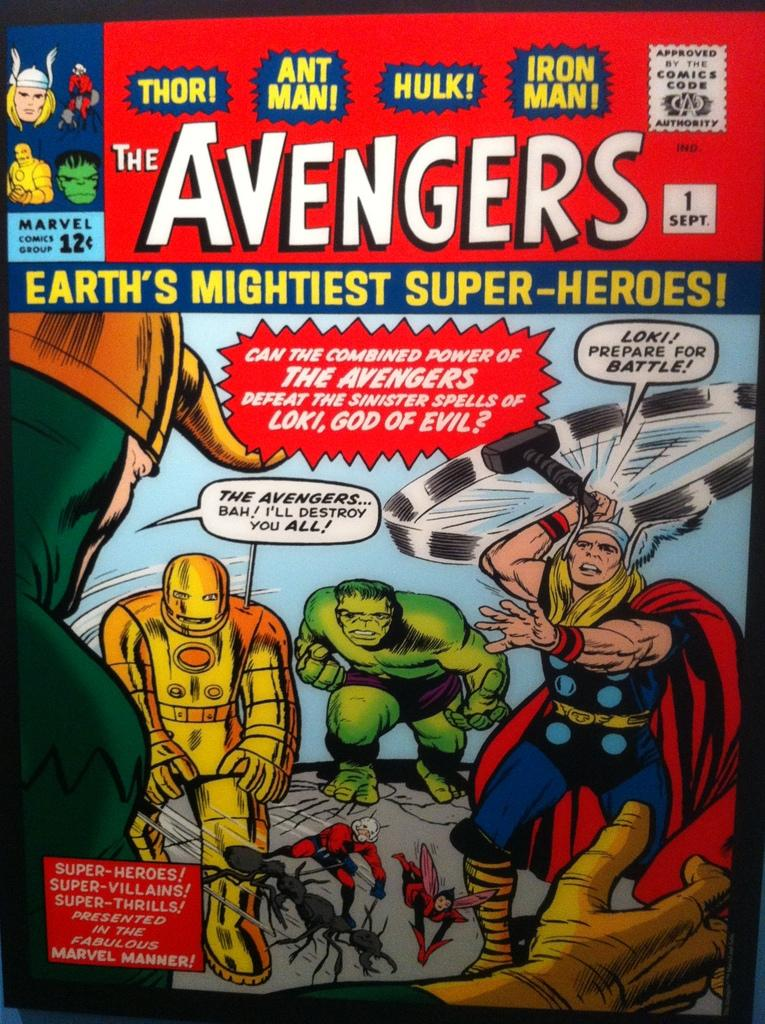<image>
Offer a succinct explanation of the picture presented. A copy of the Avengers comic book that sold for 12 cents. 